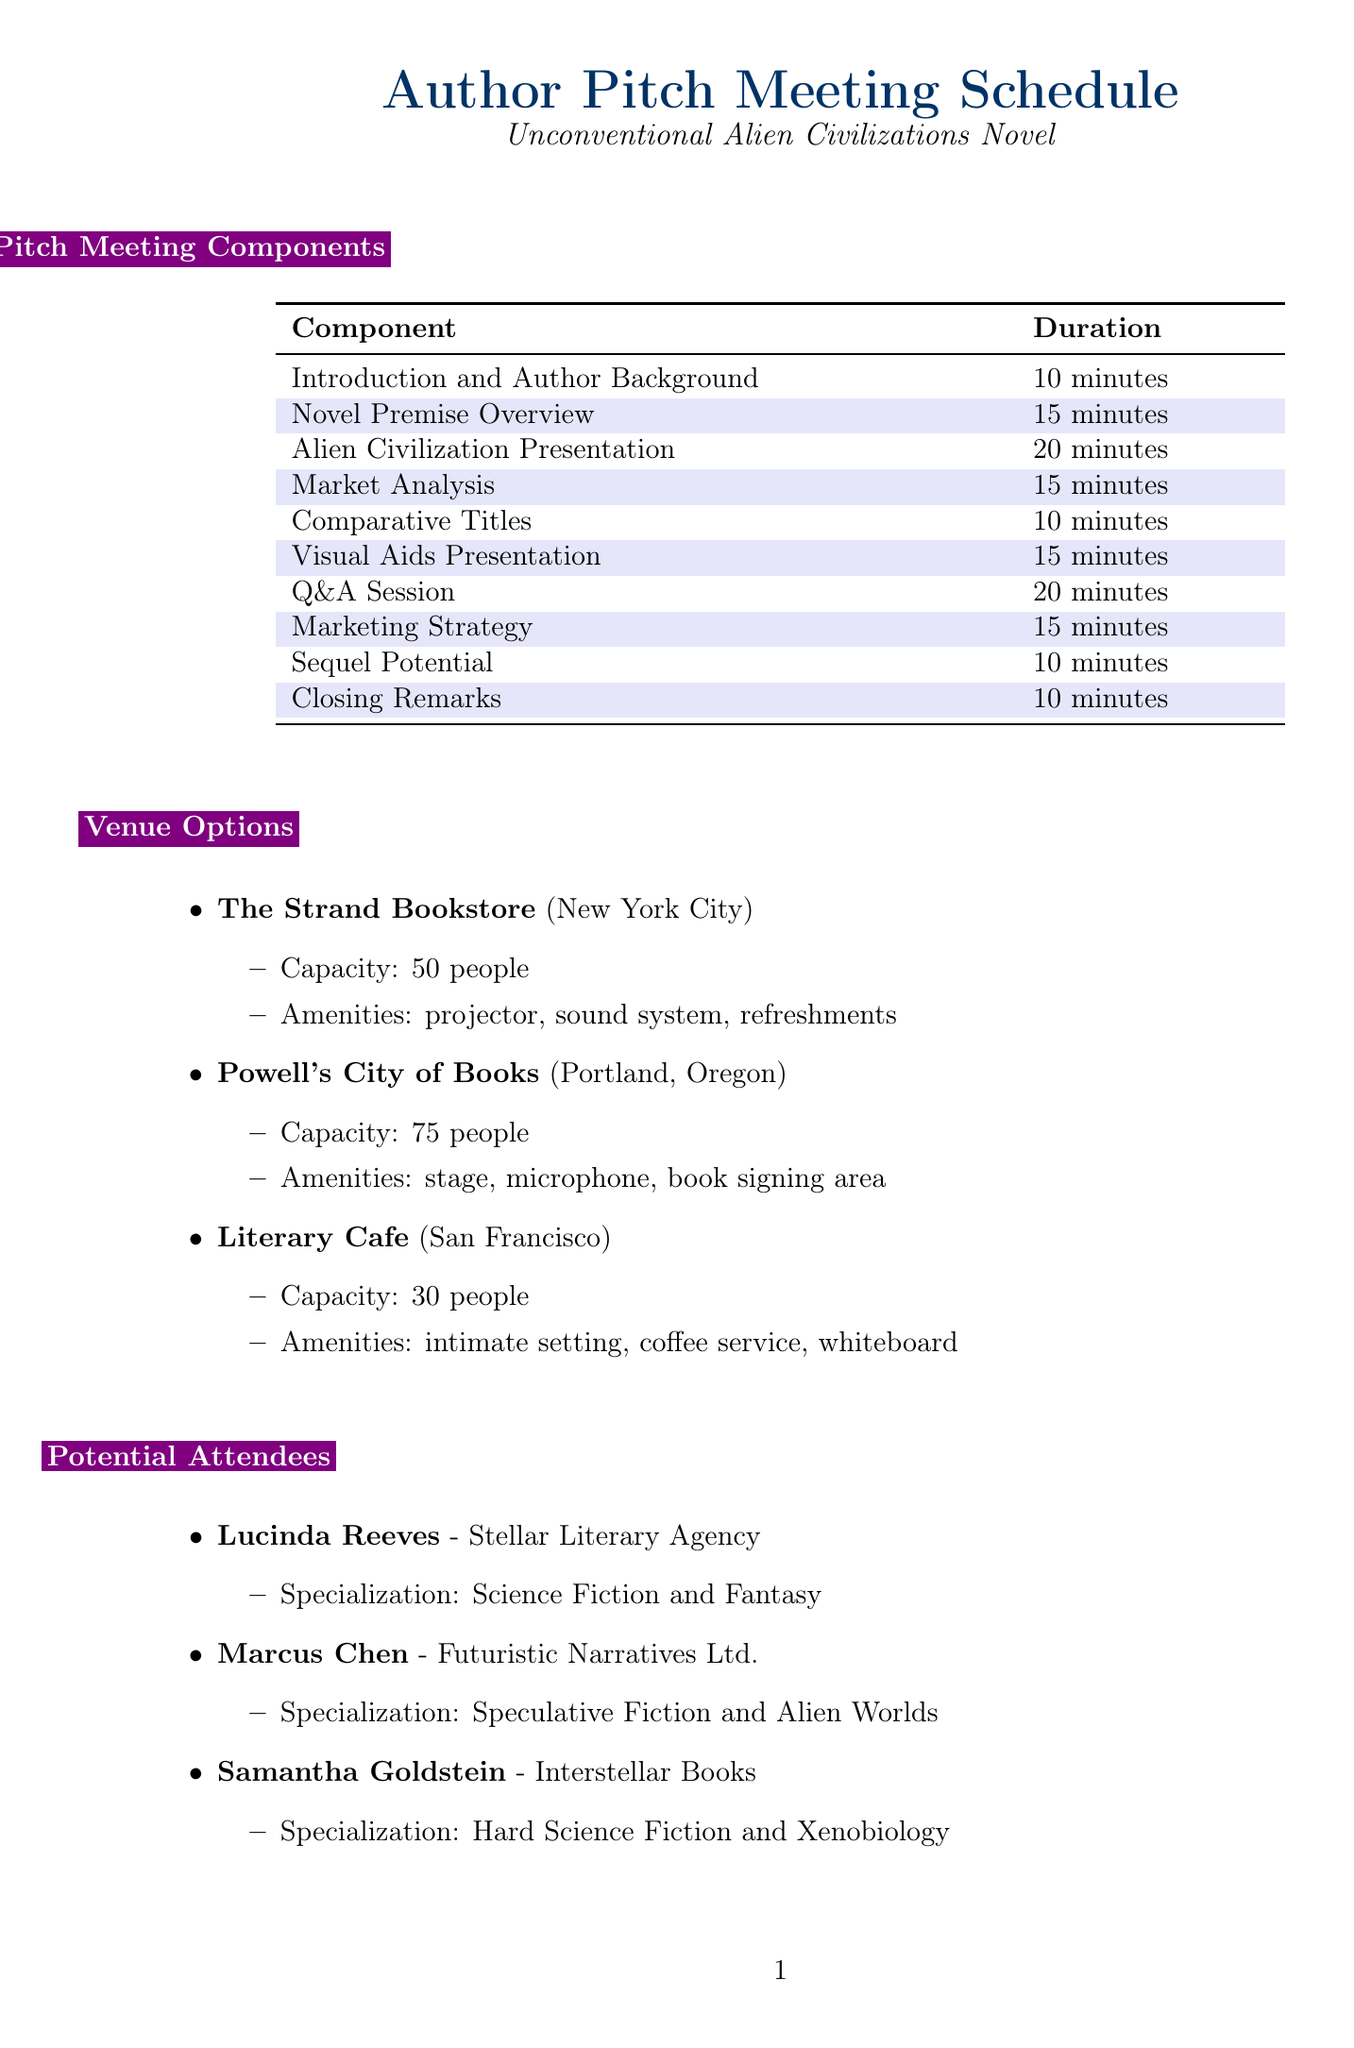What is the name of the first component? The first component listed in the pitch meeting schedule is "Introduction and Author Background."
Answer: Introduction and Author Background How long is the Q&A Session scheduled for? The Q&A Session is indicated to last for 20 minutes in the schedule.
Answer: 20 minutes Which agency does Lucinda Reeves represent? The document specifies that Lucinda Reeves is associated with Stellar Literary Agency.
Answer: Stellar Literary Agency What is the capacity of Powell's City of Books? The document states that Powell's City of Books can accommodate 75 people.
Answer: 75 people What is the topic of the Market Analysis component? The Market Analysis component discusses current trends in science fiction literature and how the novel fits into the market.
Answer: Current trends in science fiction literature How many total minutes are allocated for pitch meeting components? By adding the duration for each component, the total comes to 130 minutes (10 + 15 + 20 + 15 + 10 + 15 + 20 + 15 + 10 + 10).
Answer: 130 minutes Which venue offers an intimate setting? The document notes that the Literary Cafe provides an intimate setting for attendees.
Answer: Literary Cafe Name one potential marketing strategy listed. The preparation checklist includes a proposed plan for promoting the novel, such as potential tie-ins with sci-fi conventions.
Answer: Tie-ins with sci-fi conventions What is emphasized in the Closing Remarks? The Closing Remarks highlight the novel's unique selling points and potential impact on the science fiction genre.
Answer: Unique selling points and potential impact 